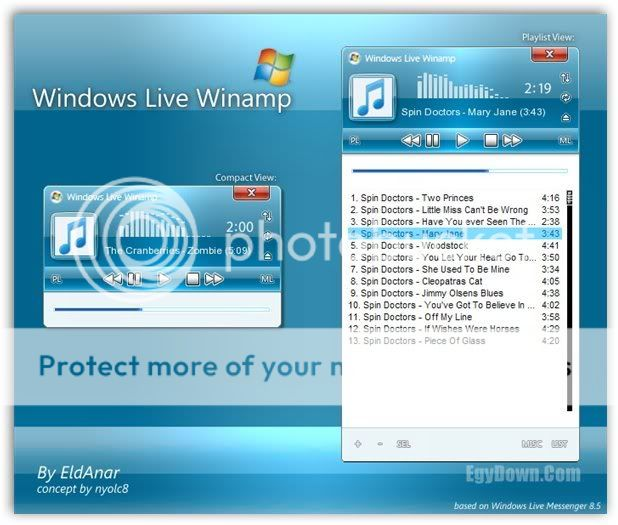Considering the highlighted track "Mary Jane" by Spin Doctors, is there any visual indication that this track is currently being played, and if so, what is it? Yes, the track "Mary Jane" by Spin Doctors displays several visual indications that it is currently being played. Firstly, the track name is highlighted in blue in the playlist, a common graphical cue used to denote active selection or ongoing activity. Furthermore, the media player's interface on the right side shows a pause button, indicating that the music is playing; should it be stopped, a play button would appear instead. The progress bar has also advanced to a point consistent with the time of playback—around 2:19—reflecting the duration into the song. The active control elements and highlighted track name collectively affirm that 'Mary Jane' is the track currently being played. 